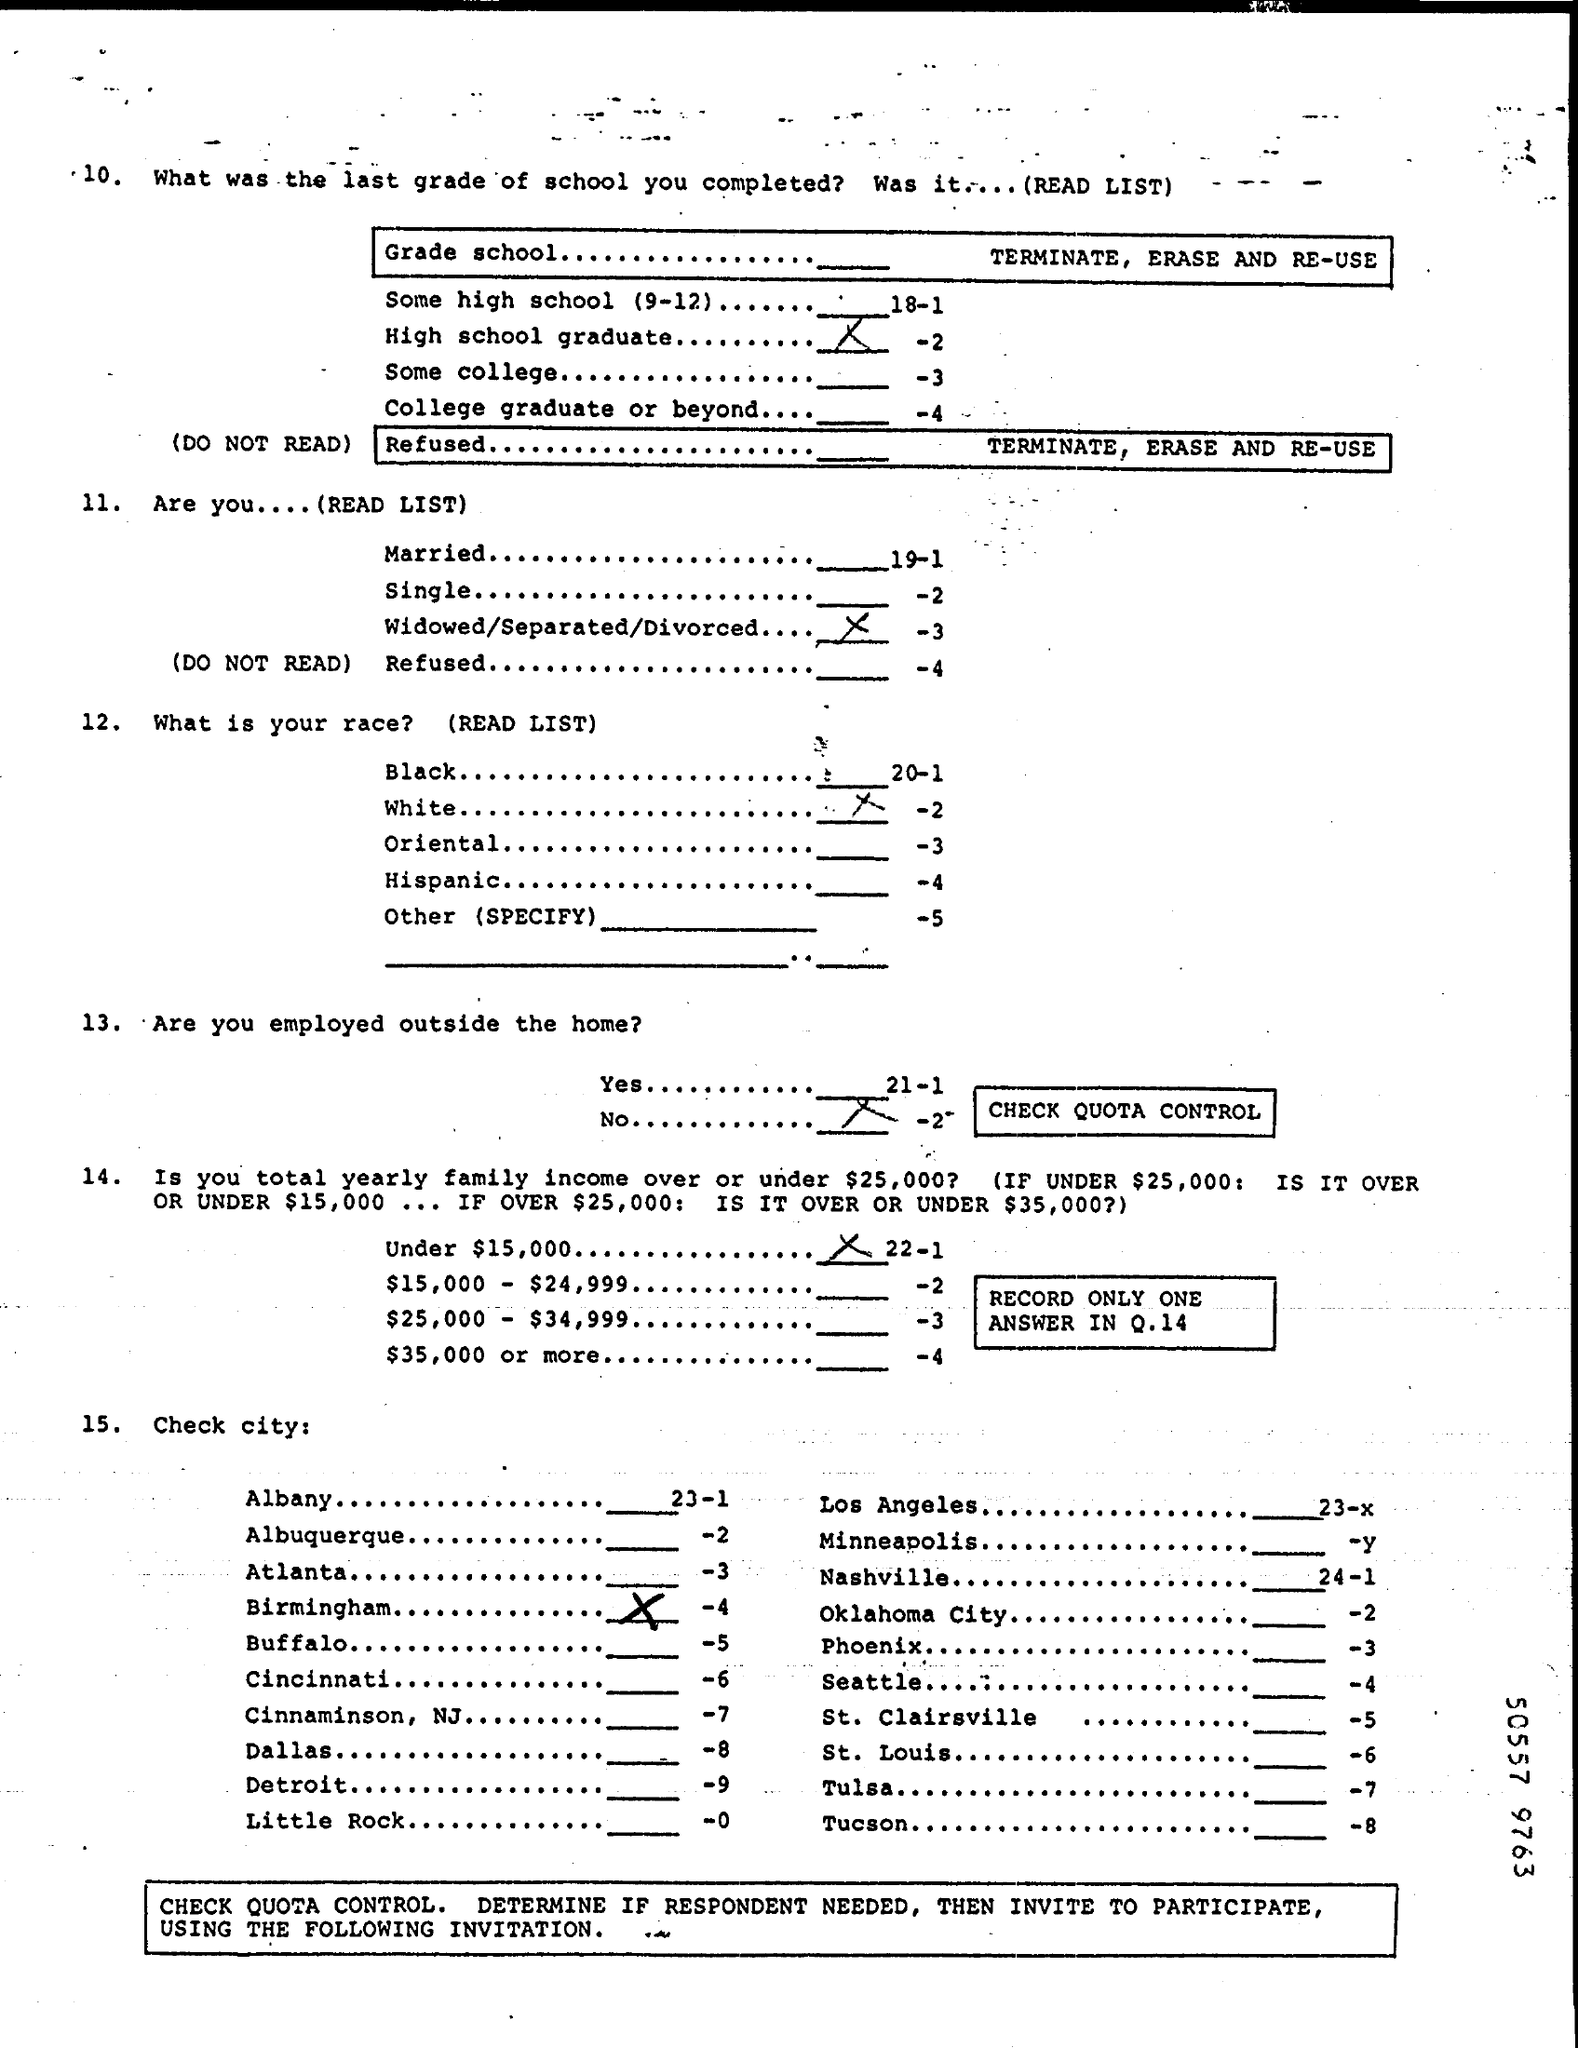Give some essential details in this illustration. What is the City? Birmingham is the name of the city. For families with an annual income of under $15,000, the total yearly income is less than $15,000. I completed grade school, and I am a high school graduate. 